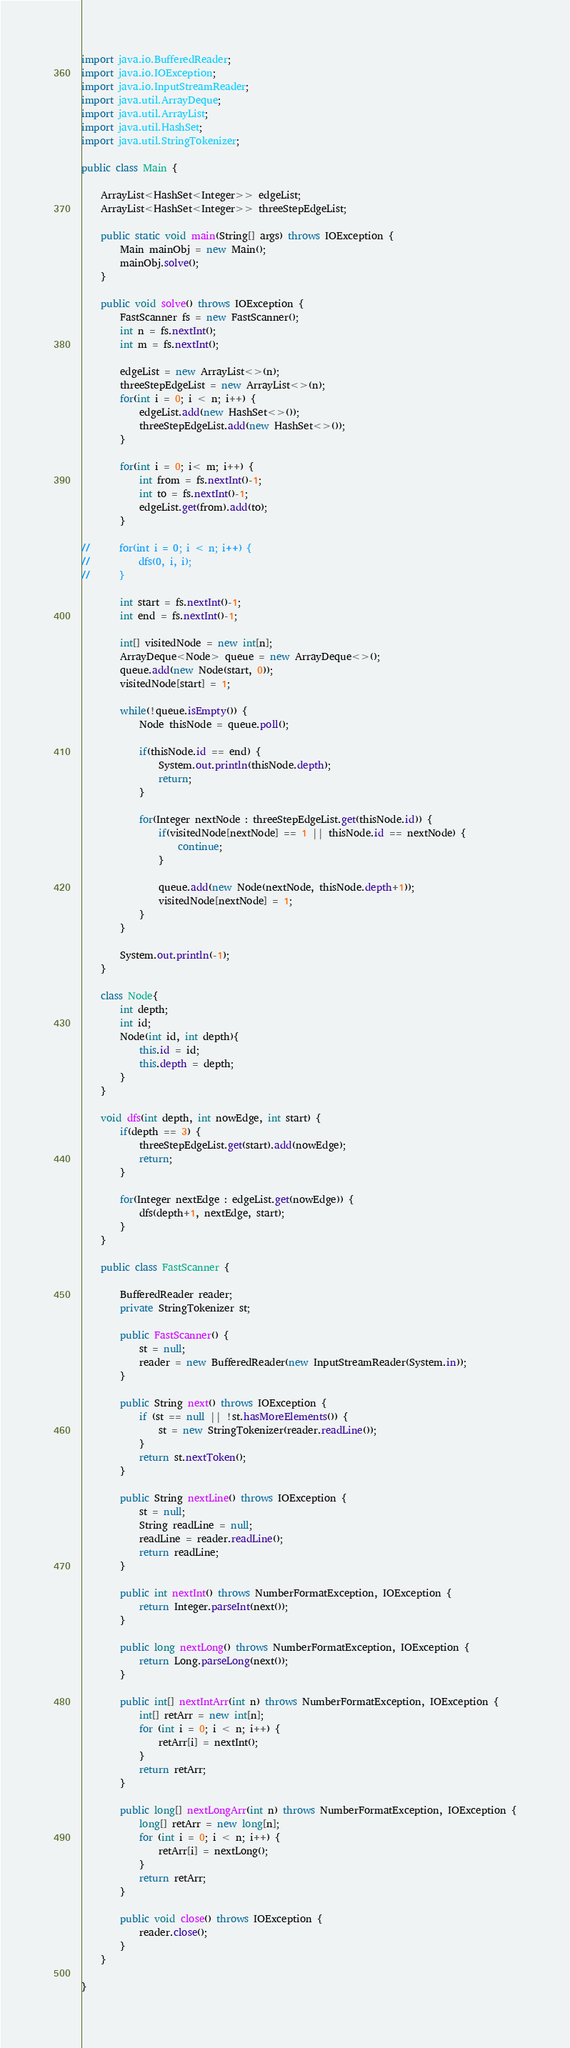<code> <loc_0><loc_0><loc_500><loc_500><_Java_>import java.io.BufferedReader;
import java.io.IOException;
import java.io.InputStreamReader;
import java.util.ArrayDeque;
import java.util.ArrayList;
import java.util.HashSet;
import java.util.StringTokenizer;

public class Main {
	
	ArrayList<HashSet<Integer>> edgeList;
	ArrayList<HashSet<Integer>> threeStepEdgeList;

	public static void main(String[] args) throws IOException {
		Main mainObj = new Main();
		mainObj.solve();
	}

	public void solve() throws IOException {
		FastScanner fs = new FastScanner();
		int n = fs.nextInt();
		int m = fs.nextInt();
		
		edgeList = new ArrayList<>(n);
		threeStepEdgeList = new ArrayList<>(n);
		for(int i = 0; i < n; i++) {
			edgeList.add(new HashSet<>());
			threeStepEdgeList.add(new HashSet<>());
		}
		
		for(int i = 0; i< m; i++) {
			int from = fs.nextInt()-1;
			int to = fs.nextInt()-1;
			edgeList.get(from).add(to);
		}
		
//		for(int i = 0; i < n; i++) {
//			dfs(0, i, i);
//		}
		
		int start = fs.nextInt()-1;
		int end = fs.nextInt()-1;
		
		int[] visitedNode = new int[n];
		ArrayDeque<Node> queue = new ArrayDeque<>();
		queue.add(new Node(start, 0));
		visitedNode[start] = 1;
		
		while(!queue.isEmpty()) {
			Node thisNode = queue.poll();
			
			if(thisNode.id == end) {
				System.out.println(thisNode.depth);
				return;
			}
			
			for(Integer nextNode : threeStepEdgeList.get(thisNode.id)) {
				if(visitedNode[nextNode] == 1 || thisNode.id == nextNode) {
					continue;
				}
				
				queue.add(new Node(nextNode, thisNode.depth+1));
				visitedNode[nextNode] = 1;
			}
		}
		
		System.out.println(-1);
	}
	
	class Node{
		int depth;
		int id;
		Node(int id, int depth){
			this.id = id;
			this.depth = depth;
		}
	}
	
	void dfs(int depth, int nowEdge, int start) {
		if(depth == 3) {
			threeStepEdgeList.get(start).add(nowEdge);
			return;
		}
		
		for(Integer nextEdge : edgeList.get(nowEdge)) {
			dfs(depth+1, nextEdge, start);
		}
	}
	
	public class FastScanner {

		BufferedReader reader;
		private StringTokenizer st;

		public FastScanner() {
			st = null;
			reader = new BufferedReader(new InputStreamReader(System.in));
		}

		public String next() throws IOException {
			if (st == null || !st.hasMoreElements()) {
				st = new StringTokenizer(reader.readLine());
			}
			return st.nextToken();
		}

		public String nextLine() throws IOException {
			st = null;
			String readLine = null;
			readLine = reader.readLine();
			return readLine;
		}

		public int nextInt() throws NumberFormatException, IOException {
			return Integer.parseInt(next());
		}

		public long nextLong() throws NumberFormatException, IOException {
			return Long.parseLong(next());
		}

		public int[] nextIntArr(int n) throws NumberFormatException, IOException {
			int[] retArr = new int[n];
			for (int i = 0; i < n; i++) {
				retArr[i] = nextInt();
			}
			return retArr;
		}

		public long[] nextLongArr(int n) throws NumberFormatException, IOException {
			long[] retArr = new long[n];
			for (int i = 0; i < n; i++) {
				retArr[i] = nextLong();
			}
			return retArr;
		}

		public void close() throws IOException {
			reader.close();
		}
	}

}
</code> 